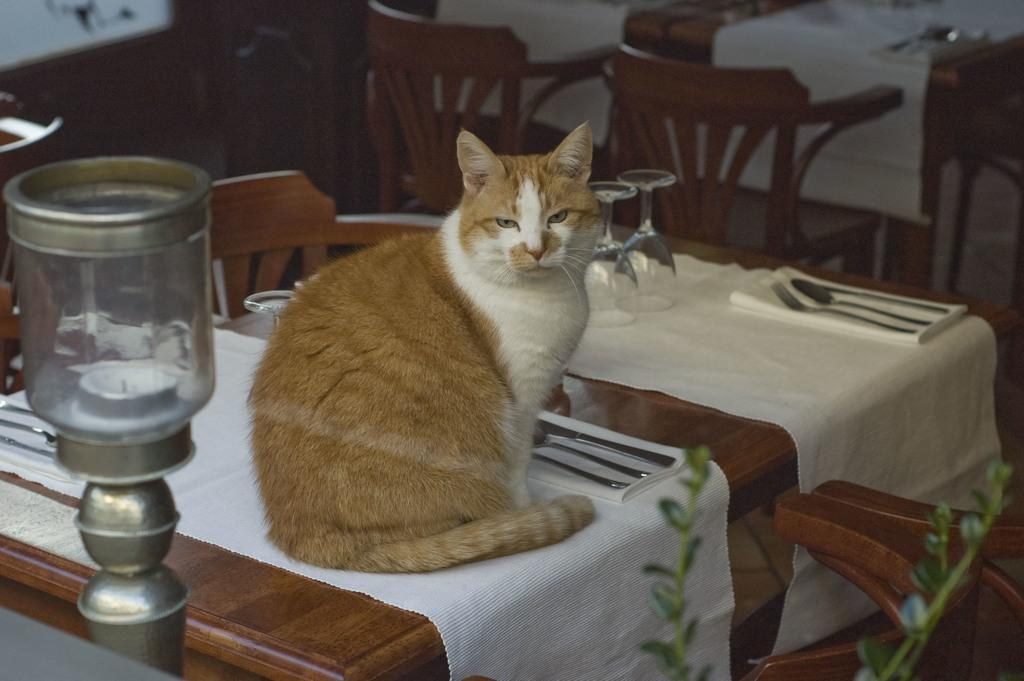How many chairs are in the room? There are many chairs in the room. What is the main piece of furniture in the room? There is a table in the room. What is sitting on the table? A cat is sitting on the table. What items can be found on the table? There are spoons, napkins, glasses, and a tablecloth on the table. Where is the candle stand located in the room? There is a candle stand in the left side of the room. How does the sand move around in the room? There is no sand present in the room; it is a room with chairs, a table, a cat, spoons, napkins, glasses, a tablecloth, and a candle stand. Is there a fireman in the room? There is no fireman present in the room; it is a room with chairs, a table, a cat, spoons, napkins, glasses, a tablecloth, and a candle stand. 